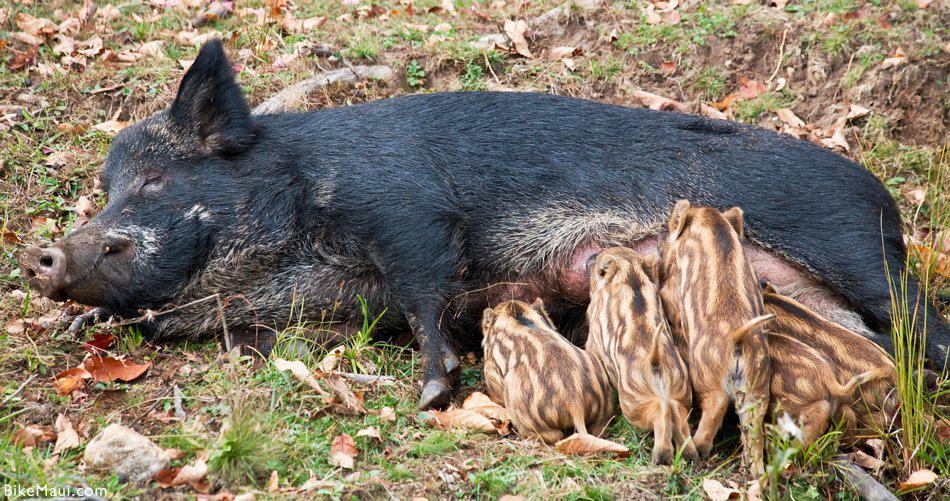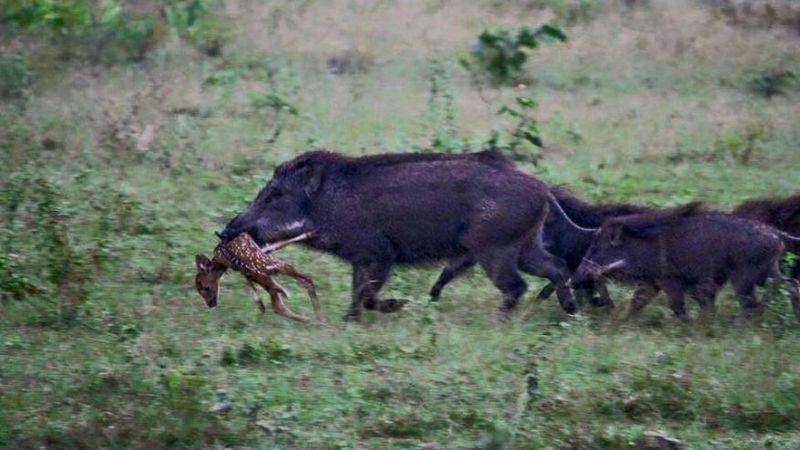The first image is the image on the left, the second image is the image on the right. Examine the images to the left and right. Is the description "In one of the image there are baby pigs near a mother pig" accurate? Answer yes or no. Yes. 